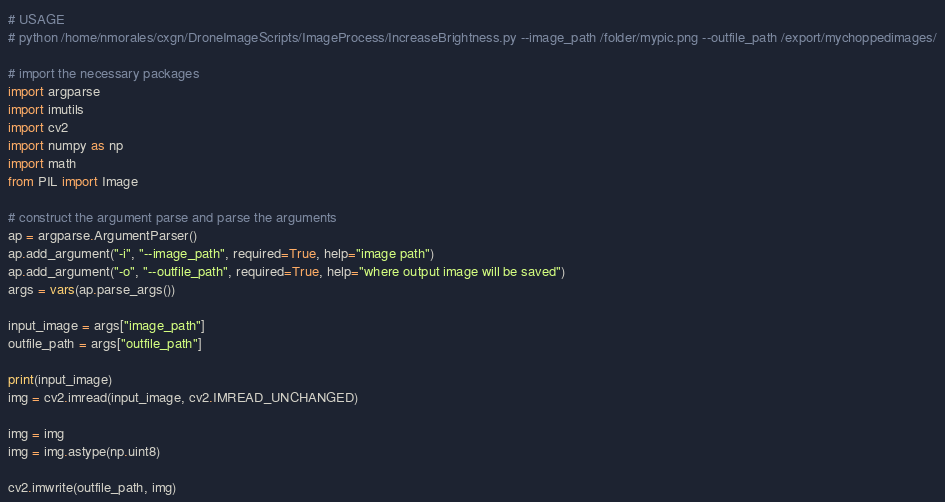<code> <loc_0><loc_0><loc_500><loc_500><_Python_># USAGE
# python /home/nmorales/cxgn/DroneImageScripts/ImageProcess/IncreaseBrightness.py --image_path /folder/mypic.png --outfile_path /export/mychoppedimages/

# import the necessary packages
import argparse
import imutils
import cv2
import numpy as np
import math
from PIL import Image

# construct the argument parse and parse the arguments
ap = argparse.ArgumentParser()
ap.add_argument("-i", "--image_path", required=True, help="image path")
ap.add_argument("-o", "--outfile_path", required=True, help="where output image will be saved")
args = vars(ap.parse_args())

input_image = args["image_path"]
outfile_path = args["outfile_path"]

print(input_image)
img = cv2.imread(input_image, cv2.IMREAD_UNCHANGED)

img = img
img = img.astype(np.uint8)

cv2.imwrite(outfile_path, img)
</code> 